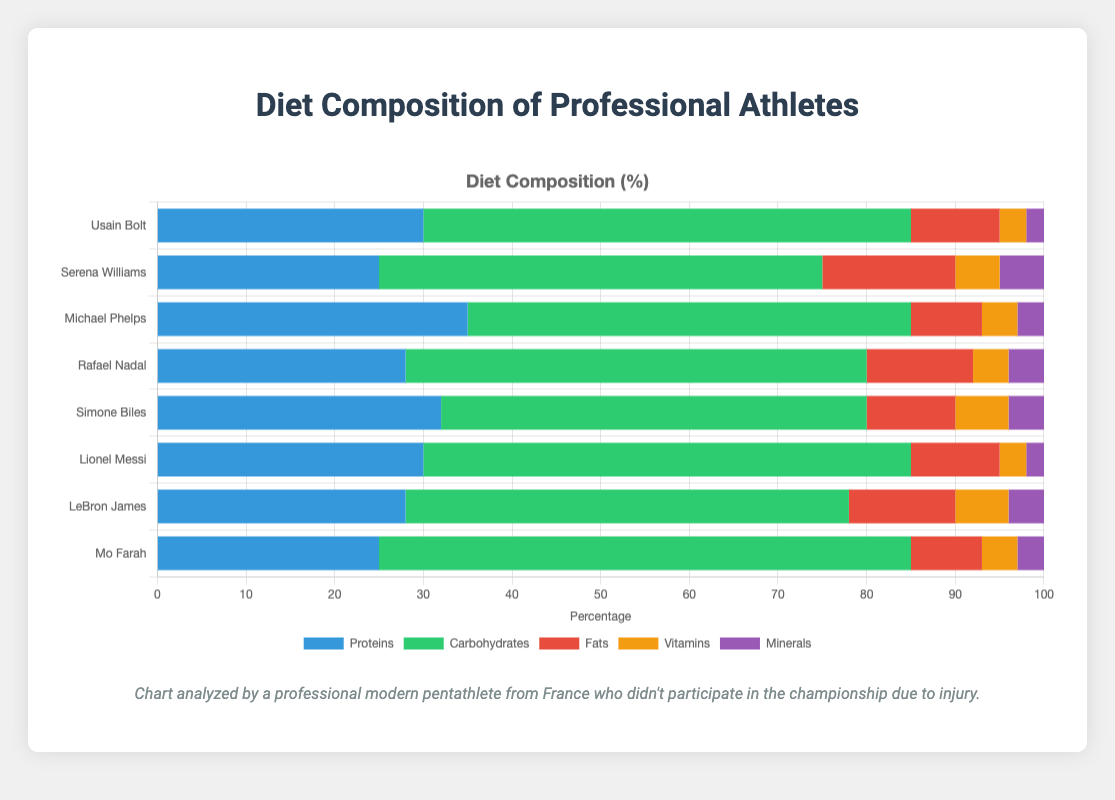What is the average percentage of proteins in the diets of all athletes? To find the average percentage of proteins, sum up the protein percentages for all athletes: 30 + 25 + 35 + 28 + 32 + 30 + 28 + 25 = 233. Then divide by the number of athletes (8): 233 / 8 = 29.125.
Answer: 29.125 Which athlete has the highest percentage of carbohydrates in their diet? By comparing the carbohydrates percentages of each athlete (55, 50, 50, 52, 48, 55, 50, 60), we see that Mo Farah has the highest percentage of 60.
Answer: Mo Farah Compare the fat percentage of Serena Williams and Michael Phelps. Which one is higher and by how much? Serena Williams has 15% fats, and Michael Phelps has 8%. The difference is 15 - 8 = 7. Therefore, Serena Williams has 7% more fats in her diet than Michael Phelps.
Answer: Serena Williams, by 7% What is the total percentage of nutrients (vitamins and minerals combined) in Lionel Messi's diet? For Lionel Messi, vitamins are 3% and minerals are 2%. Adding them together: 3 + 2 = 5.
Answer: 5 Among the listed athletes, who has the least percentage of fats in their diet? Comparing the fat percentages (10, 15, 8, 12, 10, 10, 12, 8), Michael Phelps and Mo Farah both have 8%, which is the lowest.
Answer: Michael Phelps and Mo Farah Which nutrient is the predominant one in Simone Biles' diet and what is its percentage? For Simone Biles, the nutrient with the highest percentage is carbohydrates at 48%.
Answer: Carbohydrates, 48% How many athletes have a protein percentage of 30 or more? Checking the protein percentages (30, 25, 35, 28, 32, 30, 28, 25), four athletes (Usain Bolt, Michael Phelps, Simone Biles, Lionel Messi) have 30% or more.
Answer: 4 What is the combined percentage of vitamins and minerals in Rafael Nadal's diet? Rafael Nadal has 4% vitamins and 4% minerals. Adding them together: 4 + 4 = 8.
Answer: 8 Is the proportion of carbohydrates in Mo Farah's diet higher than that in Lionel Messi's diet? Mo Farah has 60% carbohydrates while Lionel Messi has 55%. Therefore, yes, it is higher.
Answer: Yes What are the sum and average of the fat percentages across all athletes? First, sum the fat percentages: 10 + 15 + 8 + 12 + 10 + 10 + 12 + 8 = 85. Then find the average: 85 / 8 = 10.625.
Answer: Sum: 85, Average: 10.625 